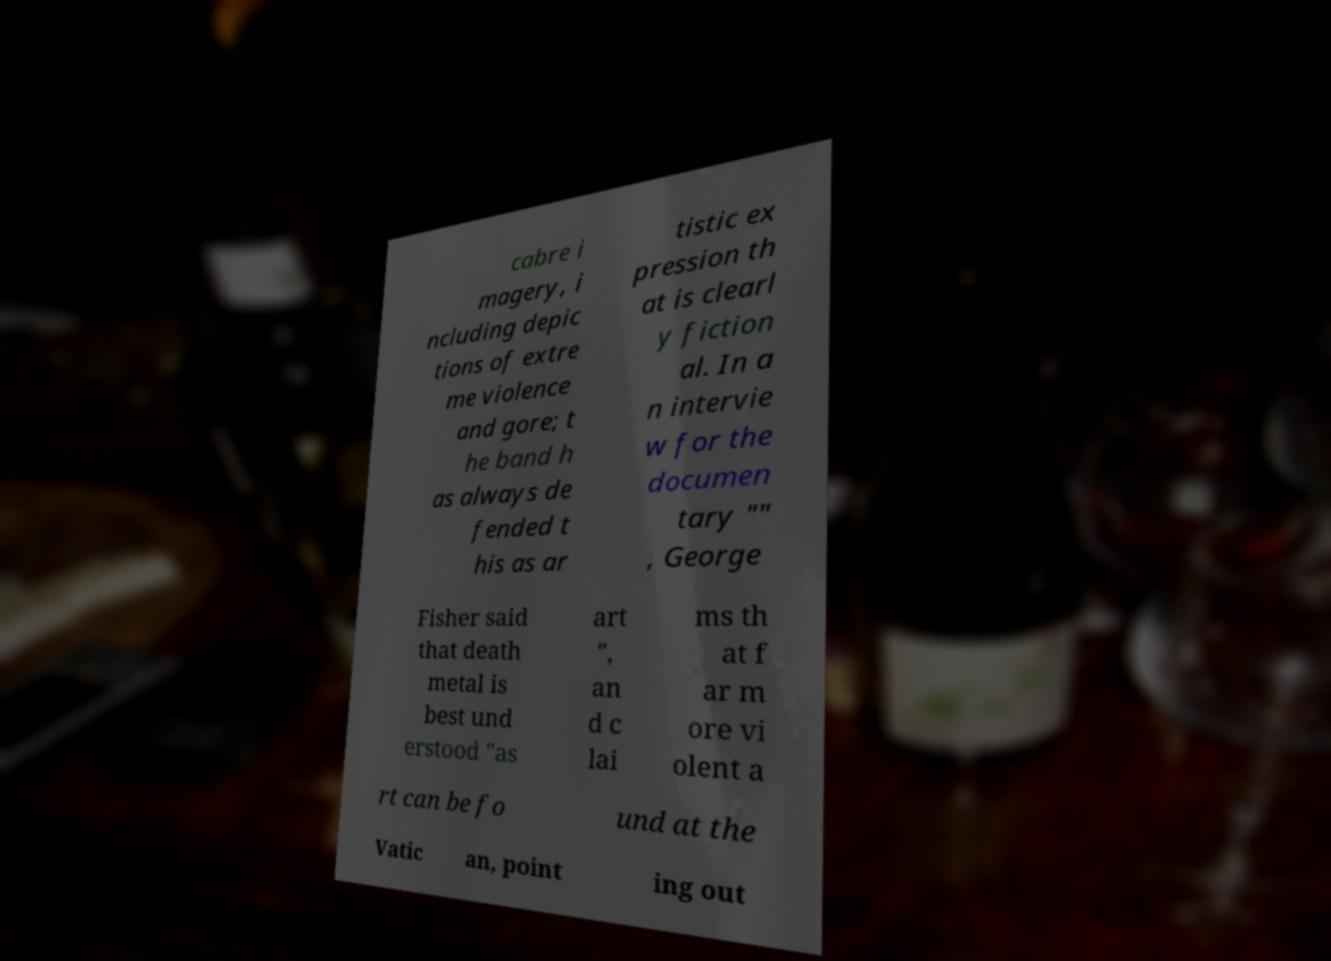Please read and relay the text visible in this image. What does it say? cabre i magery, i ncluding depic tions of extre me violence and gore; t he band h as always de fended t his as ar tistic ex pression th at is clearl y fiction al. In a n intervie w for the documen tary "" , George Fisher said that death metal is best und erstood "as art ", an d c lai ms th at f ar m ore vi olent a rt can be fo und at the Vatic an, point ing out 